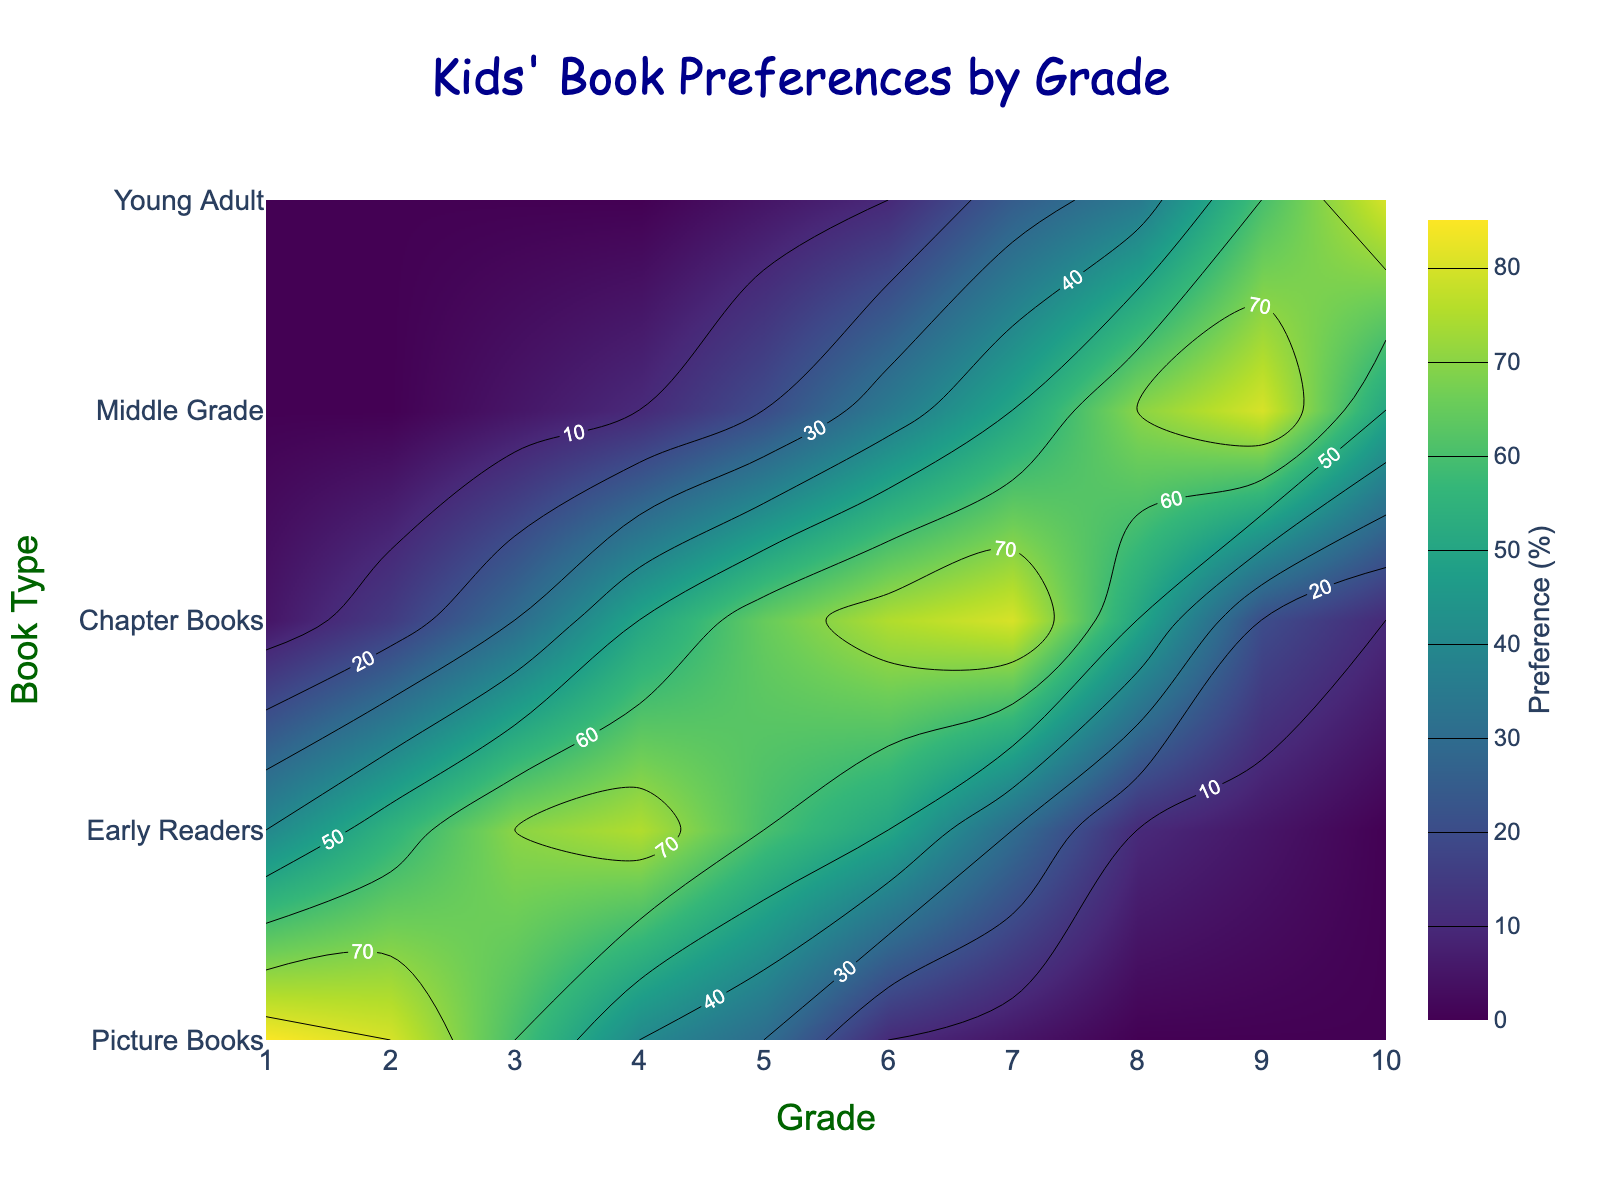How many types of books are shown in the plot? There are distinct lines for five different book types labeled on the y-axis: Picture Books, Early Readers, Chapter Books, Middle Grade, and Young Adult.
Answer: 5 What grade has the highest preference for Picture Books? The contour plot shows the highest labeled value for Picture Books at Grade 1, where the label displays the percent preference as 85.
Answer: Grade 1 What is the preference for Chapter Books in Grade 4? Locate the intersection of Grade 4 on the x-axis and Chapter Books on the y-axis in the contour plot. The label shows a value of 50%.
Answer: 50% In which grades do students show at least 50% preference for Young Adult books? Look at the labeled values for Young Adult books along the y-axis. Only Grades 9 and 10 show preferences of 60% and 80%, respectively.
Answer: Grades 9 and 10 Which type of book shows a decreasing trend in preference as students move from Grade 1 to Grade 10? Observing the labels across the contour plot, Picture Books show a high preference in Grade 1 that gradually decreases to 0% by Grade 10.
Answer: Picture Books At which grade does the preference for Early Readers peak? The contour plot label indicates that Grade 4 has the highest preference for Early Readers with a value of 75%.
Answer: Grade 4 Estimate the average preference for Middle Grade books from Grade 5 to Grade 8. Add the preferences for Middle Grade books from Grade 5 (20%), Grade 6 (35%), Grade 7 (50%), and Grade 8 (70%), then divide by 4: (20 + 35 + 50 + 70) / 4 = 43.75.
Answer: 43.75% Compare the preferences for Chapter Books and Young Adult books in Grade 9. Which is higher? In Grade 9, the preference for Chapter Books is 20%, while for Young Adult books is 60%; thus, Young Adult is higher.
Answer: Young Adult Which book type has an increasing preference trend from Grade 6 to Grade 10? Observing the labels, Young Adult books show an increasing trend from 10% in Grade 6 to 80% in Grade 10.
Answer: Young Adult What is the difference in preference for Early Readers between Grade 2 and Grade 7? From the plot, the preference for Early Readers in Grade 2 is 55%, and in Grade 7, it is 30%. The difference is 55% - 30% = 25%.
Answer: 25% 